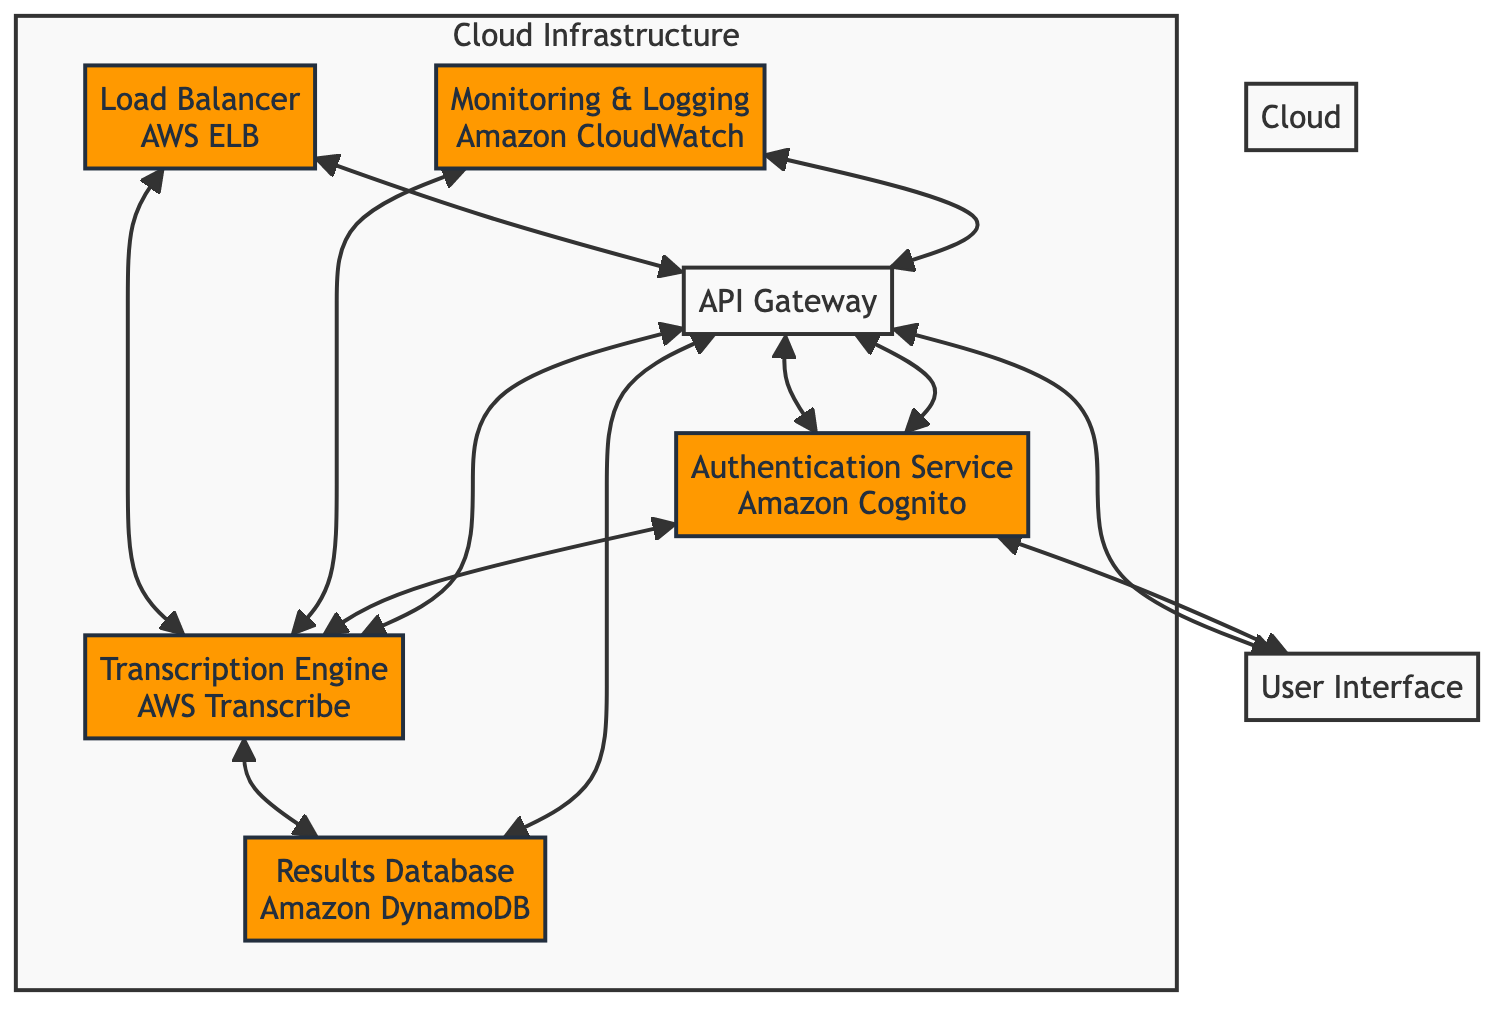What is the primary function of the API Gateway? The API Gateway manages API requests and routes them to the appropriate microservice, serving as a central point of communication between the user interface and backend services.
Answer: Manages API requests How many microservices are directly connected to the API Gateway? The API Gateway connects to four distinct components: Audio Storage, Transcription Engine, Results Database, and User Interface.
Answer: Four What service is used for Audio Storage? The diagram indicates that Audio Storage utilizes Amazon S3 for cloud-based storage of user-uploaded audio files.
Answer: Amazon S3 What is the relationship between the Transcription Engine and Results Database? The Transcription Engine sends results to the Results Database after processing audio to text, indicating a directional flow of data between these components.
Answer: Sends results Which service monitors and logs system performance? Amazon CloudWatch is designated as the service responsible for monitoring and logging the system’s performance and errors.
Answer: Amazon CloudWatch What kind of load balancing service is mentioned? The diagram specifies AWS Elastic Load Balancer (ELB) as the service used for distributing incoming traffic across services.
Answer: AWS Elastic Load Balancer (ELB) Describe the connection between User Interface and Authentication Service. The User Interface connects to the Authentication Service to manage user authentication and authorization, indicating that user actions may require verification before proceeding.
Answer: Connects for authentication What role does the Load Balancer play in the architecture? The Load Balancer distributes incoming traffic across multiple services to ensure high availability, which helps optimize resource use and maintain service continuity.
Answer: Distributes incoming traffic How does the Monitoring & Logging component connect to the system? The Monitoring & Logging component connects to both the Transcription Engine and API Gateway, allowing it to track performance and errors related to these services' operations.
Answer: Connects to two components 